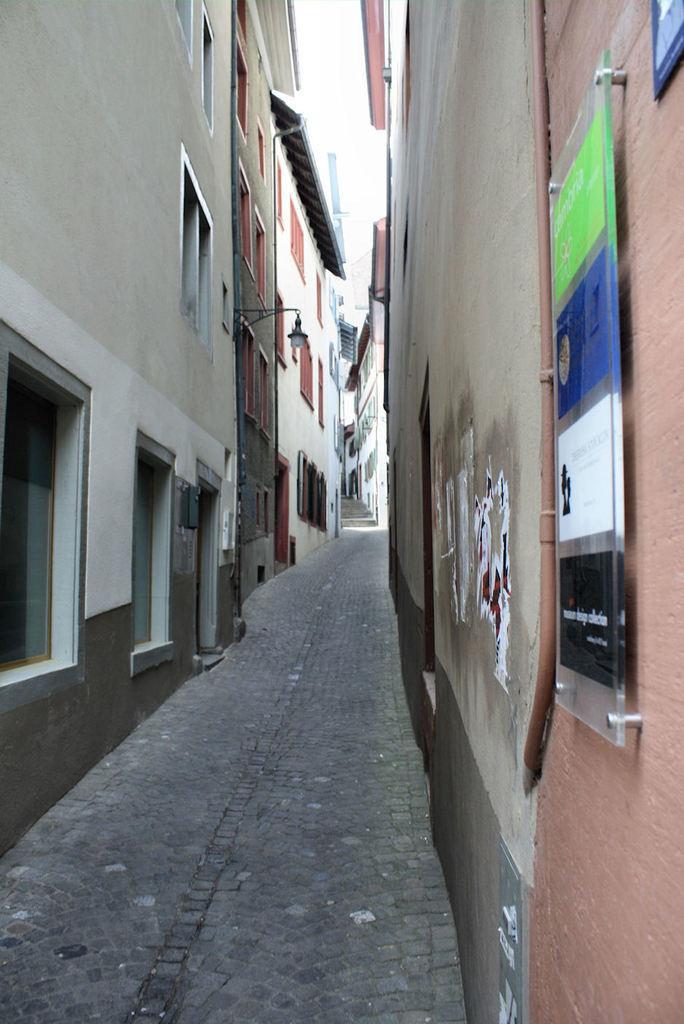Could you give a brief overview of what you see in this image? in this picture i can see street which is between two buildings and towards my right brow color building , towards my left i can white cream color building which is build with four windows, if you look little straight next to that building electrical metal which includes with white color lamp next to that i can see white color building and top of the building i can see roof which is build. 